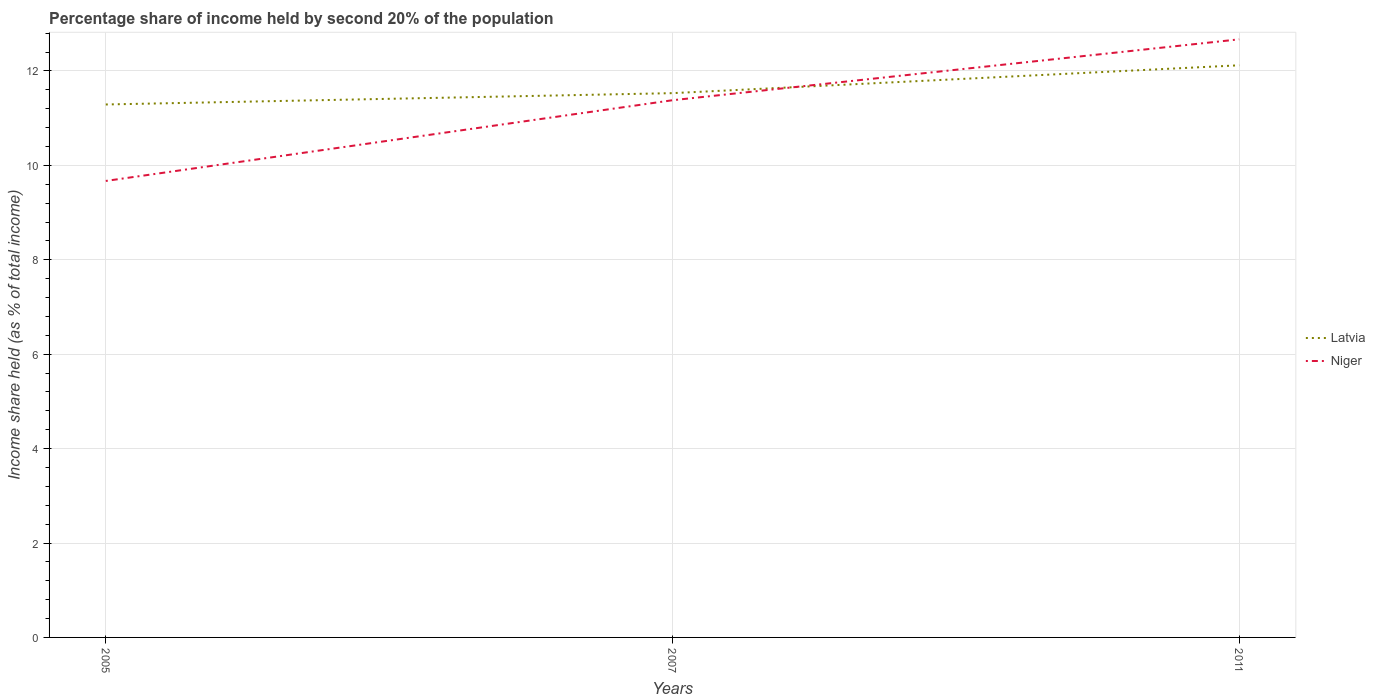Does the line corresponding to Niger intersect with the line corresponding to Latvia?
Offer a very short reply. Yes. Across all years, what is the maximum share of income held by second 20% of the population in Latvia?
Your answer should be very brief. 11.29. In which year was the share of income held by second 20% of the population in Niger maximum?
Your answer should be compact. 2005. What is the total share of income held by second 20% of the population in Latvia in the graph?
Give a very brief answer. -0.83. What is the difference between the highest and the second highest share of income held by second 20% of the population in Latvia?
Make the answer very short. 0.83. What is the difference between the highest and the lowest share of income held by second 20% of the population in Latvia?
Offer a very short reply. 1. How many lines are there?
Make the answer very short. 2. How many years are there in the graph?
Your answer should be very brief. 3. What is the difference between two consecutive major ticks on the Y-axis?
Offer a very short reply. 2. Does the graph contain any zero values?
Provide a short and direct response. No. How are the legend labels stacked?
Offer a terse response. Vertical. What is the title of the graph?
Offer a very short reply. Percentage share of income held by second 20% of the population. What is the label or title of the X-axis?
Give a very brief answer. Years. What is the label or title of the Y-axis?
Provide a succinct answer. Income share held (as % of total income). What is the Income share held (as % of total income) of Latvia in 2005?
Keep it short and to the point. 11.29. What is the Income share held (as % of total income) in Niger in 2005?
Ensure brevity in your answer.  9.67. What is the Income share held (as % of total income) in Latvia in 2007?
Keep it short and to the point. 11.53. What is the Income share held (as % of total income) of Niger in 2007?
Your response must be concise. 11.38. What is the Income share held (as % of total income) of Latvia in 2011?
Provide a short and direct response. 12.12. What is the Income share held (as % of total income) in Niger in 2011?
Give a very brief answer. 12.67. Across all years, what is the maximum Income share held (as % of total income) in Latvia?
Offer a terse response. 12.12. Across all years, what is the maximum Income share held (as % of total income) of Niger?
Offer a very short reply. 12.67. Across all years, what is the minimum Income share held (as % of total income) of Latvia?
Provide a succinct answer. 11.29. Across all years, what is the minimum Income share held (as % of total income) in Niger?
Offer a very short reply. 9.67. What is the total Income share held (as % of total income) of Latvia in the graph?
Offer a terse response. 34.94. What is the total Income share held (as % of total income) of Niger in the graph?
Make the answer very short. 33.72. What is the difference between the Income share held (as % of total income) in Latvia in 2005 and that in 2007?
Your response must be concise. -0.24. What is the difference between the Income share held (as % of total income) in Niger in 2005 and that in 2007?
Keep it short and to the point. -1.71. What is the difference between the Income share held (as % of total income) of Latvia in 2005 and that in 2011?
Provide a succinct answer. -0.83. What is the difference between the Income share held (as % of total income) of Niger in 2005 and that in 2011?
Offer a very short reply. -3. What is the difference between the Income share held (as % of total income) of Latvia in 2007 and that in 2011?
Ensure brevity in your answer.  -0.59. What is the difference between the Income share held (as % of total income) in Niger in 2007 and that in 2011?
Your answer should be compact. -1.29. What is the difference between the Income share held (as % of total income) of Latvia in 2005 and the Income share held (as % of total income) of Niger in 2007?
Your answer should be compact. -0.09. What is the difference between the Income share held (as % of total income) of Latvia in 2005 and the Income share held (as % of total income) of Niger in 2011?
Make the answer very short. -1.38. What is the difference between the Income share held (as % of total income) in Latvia in 2007 and the Income share held (as % of total income) in Niger in 2011?
Your response must be concise. -1.14. What is the average Income share held (as % of total income) in Latvia per year?
Keep it short and to the point. 11.65. What is the average Income share held (as % of total income) in Niger per year?
Your answer should be compact. 11.24. In the year 2005, what is the difference between the Income share held (as % of total income) in Latvia and Income share held (as % of total income) in Niger?
Your response must be concise. 1.62. In the year 2011, what is the difference between the Income share held (as % of total income) in Latvia and Income share held (as % of total income) in Niger?
Keep it short and to the point. -0.55. What is the ratio of the Income share held (as % of total income) in Latvia in 2005 to that in 2007?
Your answer should be compact. 0.98. What is the ratio of the Income share held (as % of total income) of Niger in 2005 to that in 2007?
Ensure brevity in your answer.  0.85. What is the ratio of the Income share held (as % of total income) in Latvia in 2005 to that in 2011?
Give a very brief answer. 0.93. What is the ratio of the Income share held (as % of total income) of Niger in 2005 to that in 2011?
Your answer should be very brief. 0.76. What is the ratio of the Income share held (as % of total income) of Latvia in 2007 to that in 2011?
Provide a short and direct response. 0.95. What is the ratio of the Income share held (as % of total income) of Niger in 2007 to that in 2011?
Offer a very short reply. 0.9. What is the difference between the highest and the second highest Income share held (as % of total income) in Latvia?
Give a very brief answer. 0.59. What is the difference between the highest and the second highest Income share held (as % of total income) of Niger?
Make the answer very short. 1.29. What is the difference between the highest and the lowest Income share held (as % of total income) of Latvia?
Keep it short and to the point. 0.83. 